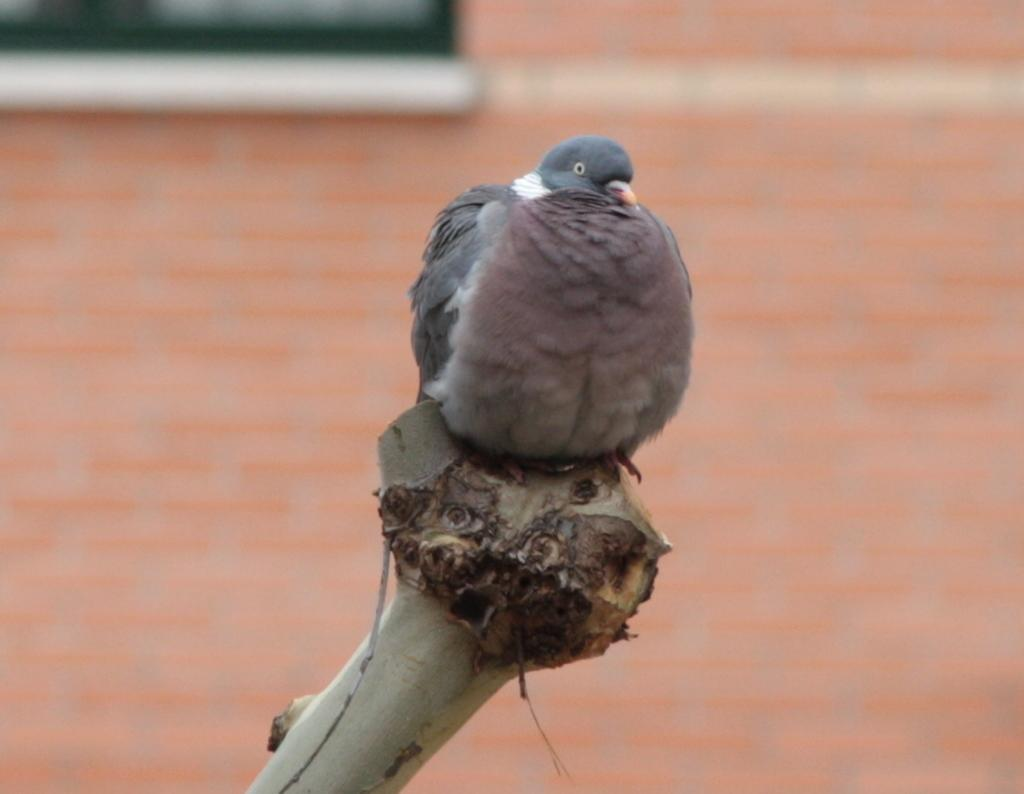Where was the image taken? The image was taken outdoors. What can be seen in the background of the image? There is a wall with a window in the background. What is the bird doing in the image? The bird is on the bark of a tree in the middle of the image. How many oranges are hanging from the tree in the image? There are no oranges visible in the image; it features a bird on the bark of a tree. Is there a swing in the image? There is no swing present in the image. 